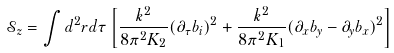Convert formula to latex. <formula><loc_0><loc_0><loc_500><loc_500>\mathcal { S } _ { z } = \int d ^ { 2 } r d \tau \left [ \frac { k ^ { 2 } } { 8 \pi ^ { 2 } K _ { 2 } } ( \partial _ { \tau } b _ { i } ) ^ { 2 } + \frac { k ^ { 2 } } { 8 \pi ^ { 2 } K _ { 1 } } ( \partial _ { x } b _ { y } - \partial _ { y } b _ { x } ) ^ { 2 } \right ]</formula> 